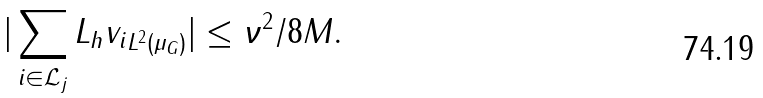Convert formula to latex. <formula><loc_0><loc_0><loc_500><loc_500>| \sum _ { i \in \mathcal { L } _ { j } } { \| L _ { h } v _ { i } \| _ { L ^ { 2 } ( \mu _ { G } ) } } | \leq \nu ^ { 2 } / 8 M .</formula> 